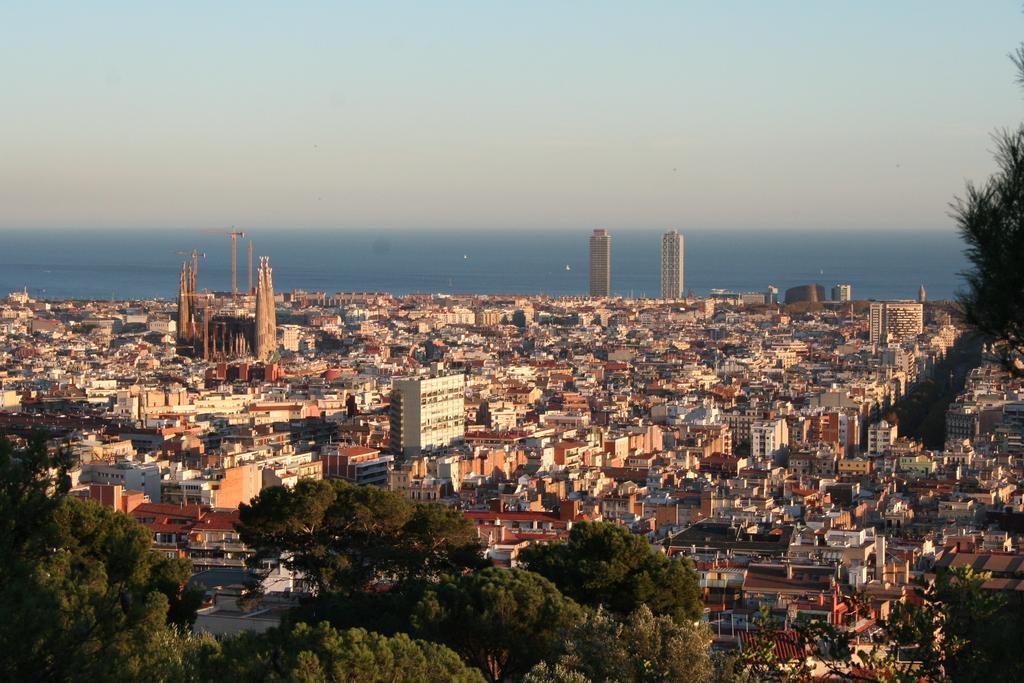Describe this image in one or two sentences. In this image, we can see buildings, trees, towers, poles and there are vehicles. At the top, there is sky. 